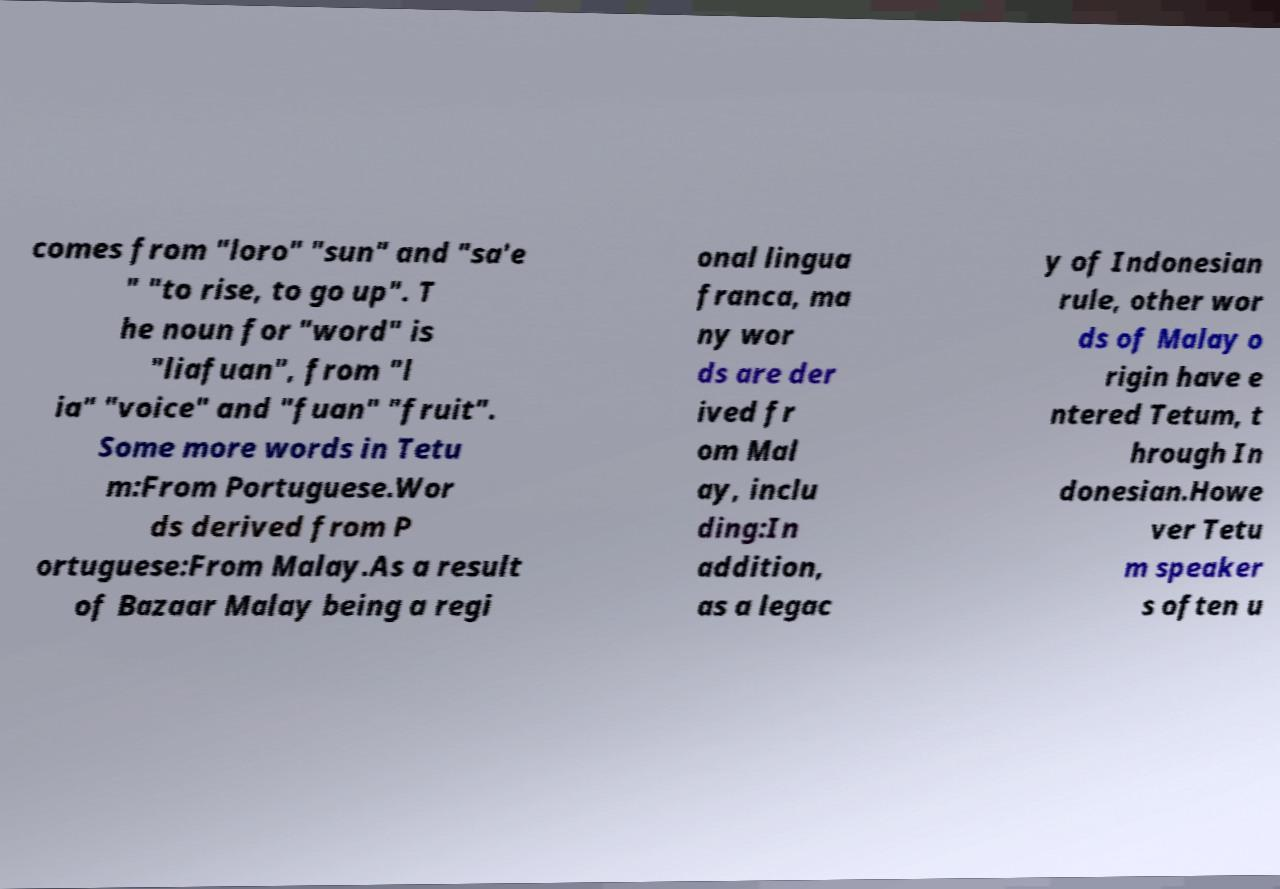There's text embedded in this image that I need extracted. Can you transcribe it verbatim? comes from "loro" "sun" and "sa'e " "to rise, to go up". T he noun for "word" is "liafuan", from "l ia" "voice" and "fuan" "fruit". Some more words in Tetu m:From Portuguese.Wor ds derived from P ortuguese:From Malay.As a result of Bazaar Malay being a regi onal lingua franca, ma ny wor ds are der ived fr om Mal ay, inclu ding:In addition, as a legac y of Indonesian rule, other wor ds of Malay o rigin have e ntered Tetum, t hrough In donesian.Howe ver Tetu m speaker s often u 